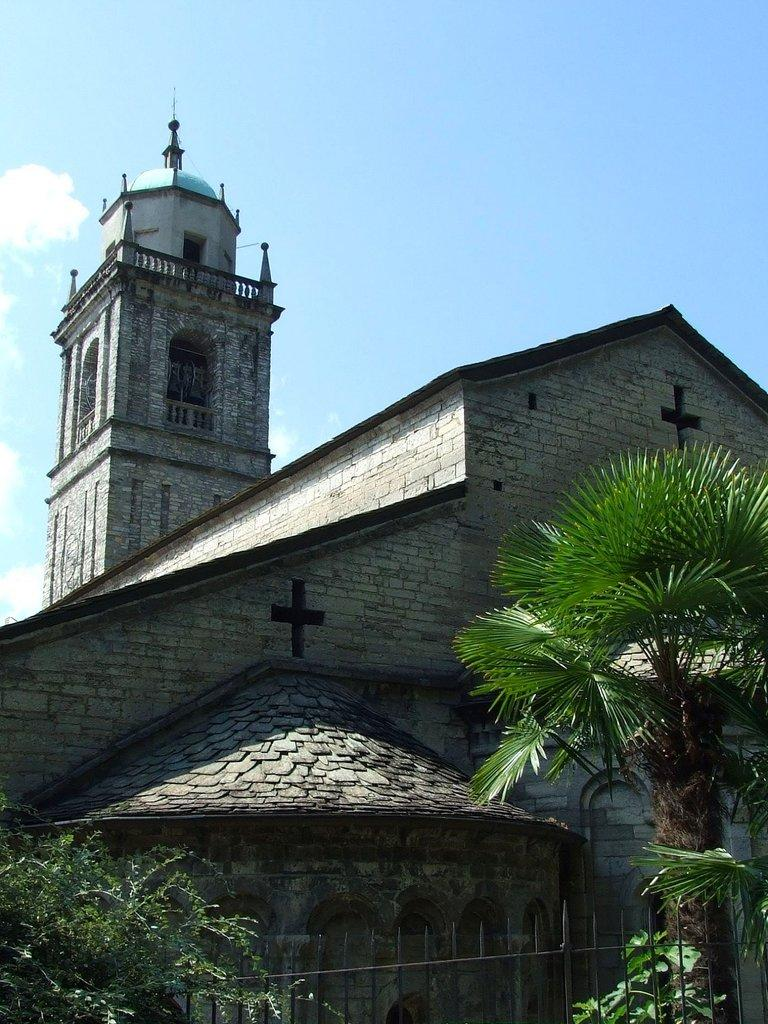What type of structure is visible in the image? There is a building in the image. What is located in the foreground of the image? There is a railing in the foreground of the image. What can be seen behind the railing? There are trees behind the railing. What is visible at the top of the image? The sky is visible at the top of the image. What can be observed in the sky? There are clouds in the sky. How does the vegetable contribute to the structure of the building in the image? There is no vegetable present in the image, and therefore it does not contribute to the structure of the building. 